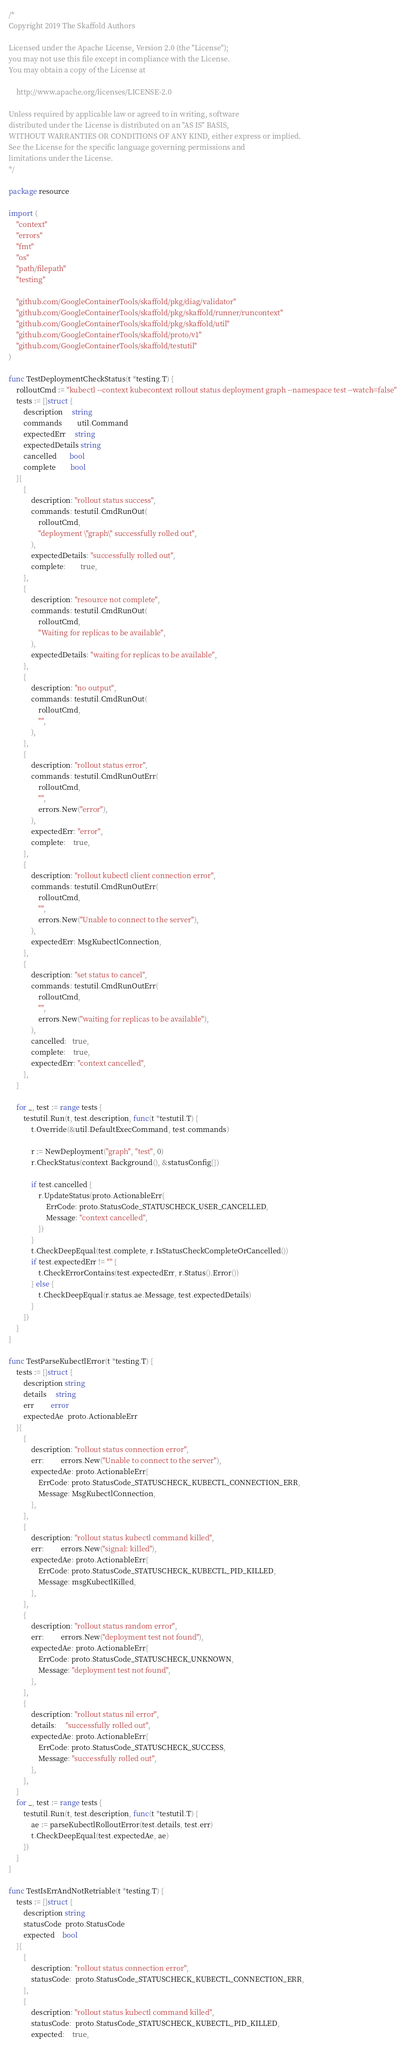Convert code to text. <code><loc_0><loc_0><loc_500><loc_500><_Go_>/*
Copyright 2019 The Skaffold Authors

Licensed under the Apache License, Version 2.0 (the "License");
you may not use this file except in compliance with the License.
You may obtain a copy of the License at

    http://www.apache.org/licenses/LICENSE-2.0

Unless required by applicable law or agreed to in writing, software
distributed under the License is distributed on an "AS IS" BASIS,
WITHOUT WARRANTIES OR CONDITIONS OF ANY KIND, either express or implied.
See the License for the specific language governing permissions and
limitations under the License.
*/

package resource

import (
	"context"
	"errors"
	"fmt"
	"os"
	"path/filepath"
	"testing"

	"github.com/GoogleContainerTools/skaffold/pkg/diag/validator"
	"github.com/GoogleContainerTools/skaffold/pkg/skaffold/runner/runcontext"
	"github.com/GoogleContainerTools/skaffold/pkg/skaffold/util"
	"github.com/GoogleContainerTools/skaffold/proto/v1"
	"github.com/GoogleContainerTools/skaffold/testutil"
)

func TestDeploymentCheckStatus(t *testing.T) {
	rolloutCmd := "kubectl --context kubecontext rollout status deployment graph --namespace test --watch=false"
	tests := []struct {
		description     string
		commands        util.Command
		expectedErr     string
		expectedDetails string
		cancelled       bool
		complete        bool
	}{
		{
			description: "rollout status success",
			commands: testutil.CmdRunOut(
				rolloutCmd,
				"deployment \"graph\" successfully rolled out",
			),
			expectedDetails: "successfully rolled out",
			complete:        true,
		},
		{
			description: "resource not complete",
			commands: testutil.CmdRunOut(
				rolloutCmd,
				"Waiting for replicas to be available",
			),
			expectedDetails: "waiting for replicas to be available",
		},
		{
			description: "no output",
			commands: testutil.CmdRunOut(
				rolloutCmd,
				"",
			),
		},
		{
			description: "rollout status error",
			commands: testutil.CmdRunOutErr(
				rolloutCmd,
				"",
				errors.New("error"),
			),
			expectedErr: "error",
			complete:    true,
		},
		{
			description: "rollout kubectl client connection error",
			commands: testutil.CmdRunOutErr(
				rolloutCmd,
				"",
				errors.New("Unable to connect to the server"),
			),
			expectedErr: MsgKubectlConnection,
		},
		{
			description: "set status to cancel",
			commands: testutil.CmdRunOutErr(
				rolloutCmd,
				"",
				errors.New("waiting for replicas to be available"),
			),
			cancelled:   true,
			complete:    true,
			expectedErr: "context cancelled",
		},
	}

	for _, test := range tests {
		testutil.Run(t, test.description, func(t *testutil.T) {
			t.Override(&util.DefaultExecCommand, test.commands)

			r := NewDeployment("graph", "test", 0)
			r.CheckStatus(context.Background(), &statusConfig{})

			if test.cancelled {
				r.UpdateStatus(proto.ActionableErr{
					ErrCode: proto.StatusCode_STATUSCHECK_USER_CANCELLED,
					Message: "context cancelled",
				})
			}
			t.CheckDeepEqual(test.complete, r.IsStatusCheckCompleteOrCancelled())
			if test.expectedErr != "" {
				t.CheckErrorContains(test.expectedErr, r.Status().Error())
			} else {
				t.CheckDeepEqual(r.status.ae.Message, test.expectedDetails)
			}
		})
	}
}

func TestParseKubectlError(t *testing.T) {
	tests := []struct {
		description string
		details     string
		err         error
		expectedAe  proto.ActionableErr
	}{
		{
			description: "rollout status connection error",
			err:         errors.New("Unable to connect to the server"),
			expectedAe: proto.ActionableErr{
				ErrCode: proto.StatusCode_STATUSCHECK_KUBECTL_CONNECTION_ERR,
				Message: MsgKubectlConnection,
			},
		},
		{
			description: "rollout status kubectl command killed",
			err:         errors.New("signal: killed"),
			expectedAe: proto.ActionableErr{
				ErrCode: proto.StatusCode_STATUSCHECK_KUBECTL_PID_KILLED,
				Message: msgKubectlKilled,
			},
		},
		{
			description: "rollout status random error",
			err:         errors.New("deployment test not found"),
			expectedAe: proto.ActionableErr{
				ErrCode: proto.StatusCode_STATUSCHECK_UNKNOWN,
				Message: "deployment test not found",
			},
		},
		{
			description: "rollout status nil error",
			details:     "successfully rolled out",
			expectedAe: proto.ActionableErr{
				ErrCode: proto.StatusCode_STATUSCHECK_SUCCESS,
				Message: "successfully rolled out",
			},
		},
	}
	for _, test := range tests {
		testutil.Run(t, test.description, func(t *testutil.T) {
			ae := parseKubectlRolloutError(test.details, test.err)
			t.CheckDeepEqual(test.expectedAe, ae)
		})
	}
}

func TestIsErrAndNotRetriable(t *testing.T) {
	tests := []struct {
		description string
		statusCode  proto.StatusCode
		expected    bool
	}{
		{
			description: "rollout status connection error",
			statusCode:  proto.StatusCode_STATUSCHECK_KUBECTL_CONNECTION_ERR,
		},
		{
			description: "rollout status kubectl command killed",
			statusCode:  proto.StatusCode_STATUSCHECK_KUBECTL_PID_KILLED,
			expected:    true,</code> 